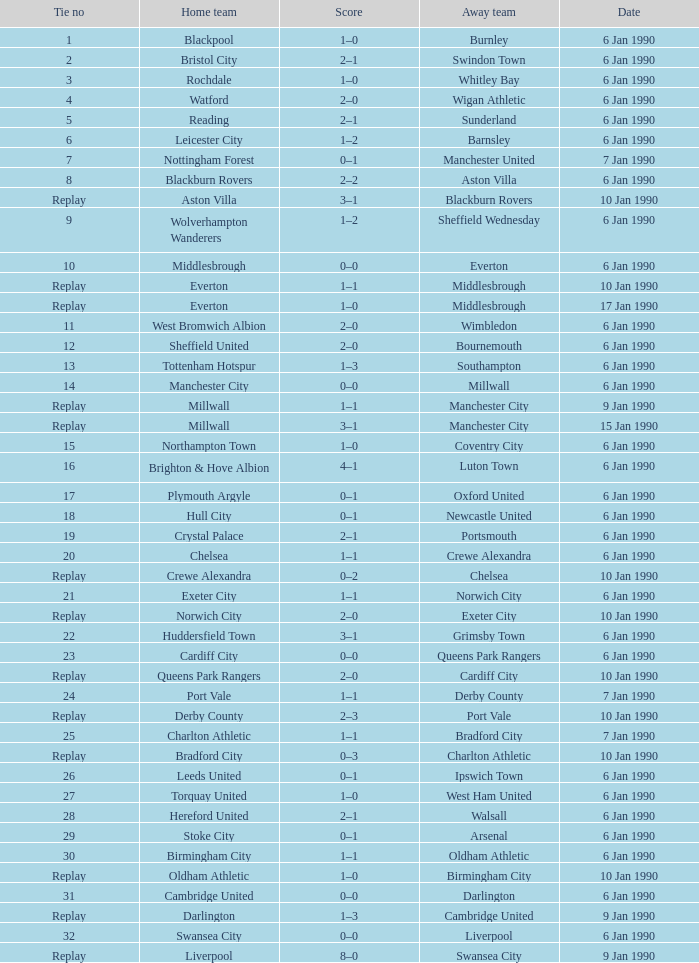During the game on january 10, 1990, what was the final score against exeter city as the visiting team? 2–0. 